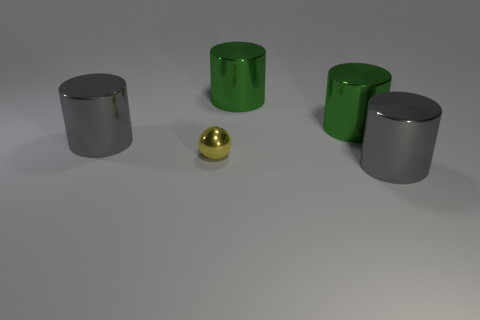How is the lighting in the scene affecting the appearance of the objects? The lighting in the scene is overhead and slightly diffused, creating soft shadows on the side of the objects opposite to the light source. The reflective surfaces of the cylinders and the ball produce subtle highlights, emphasising their smooth texture and adding depth to the composition.  If you were to describe the mood or atmosphere this image conveys, what would you say? The image conveys a stark, minimalist mood. The simplicity of the objects, the neutral background, and the smooth, clean lines create a tranquil and modern atmosphere. The subdued lighting adds to the calm and orderly feel of the scene. 